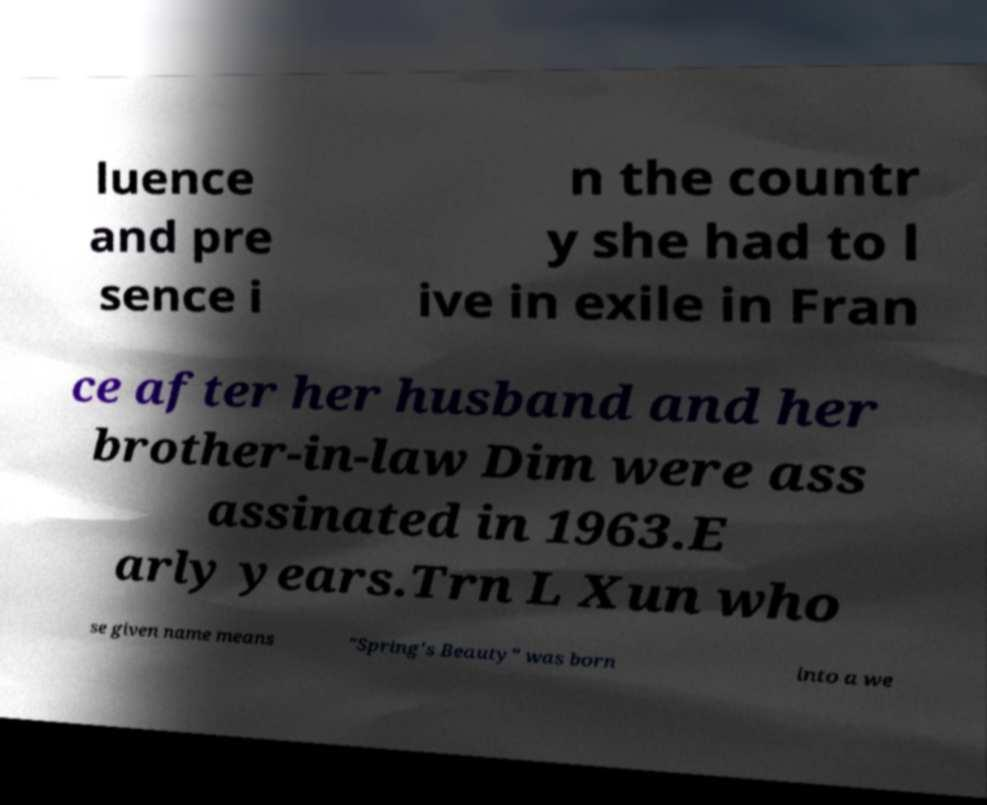Could you assist in decoding the text presented in this image and type it out clearly? luence and pre sence i n the countr y she had to l ive in exile in Fran ce after her husband and her brother-in-law Dim were ass assinated in 1963.E arly years.Trn L Xun who se given name means "Spring's Beauty" was born into a we 